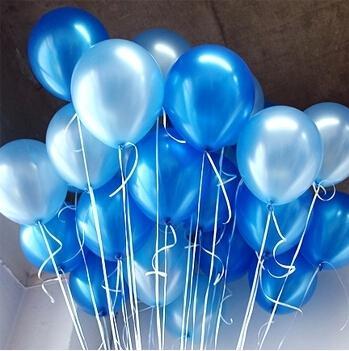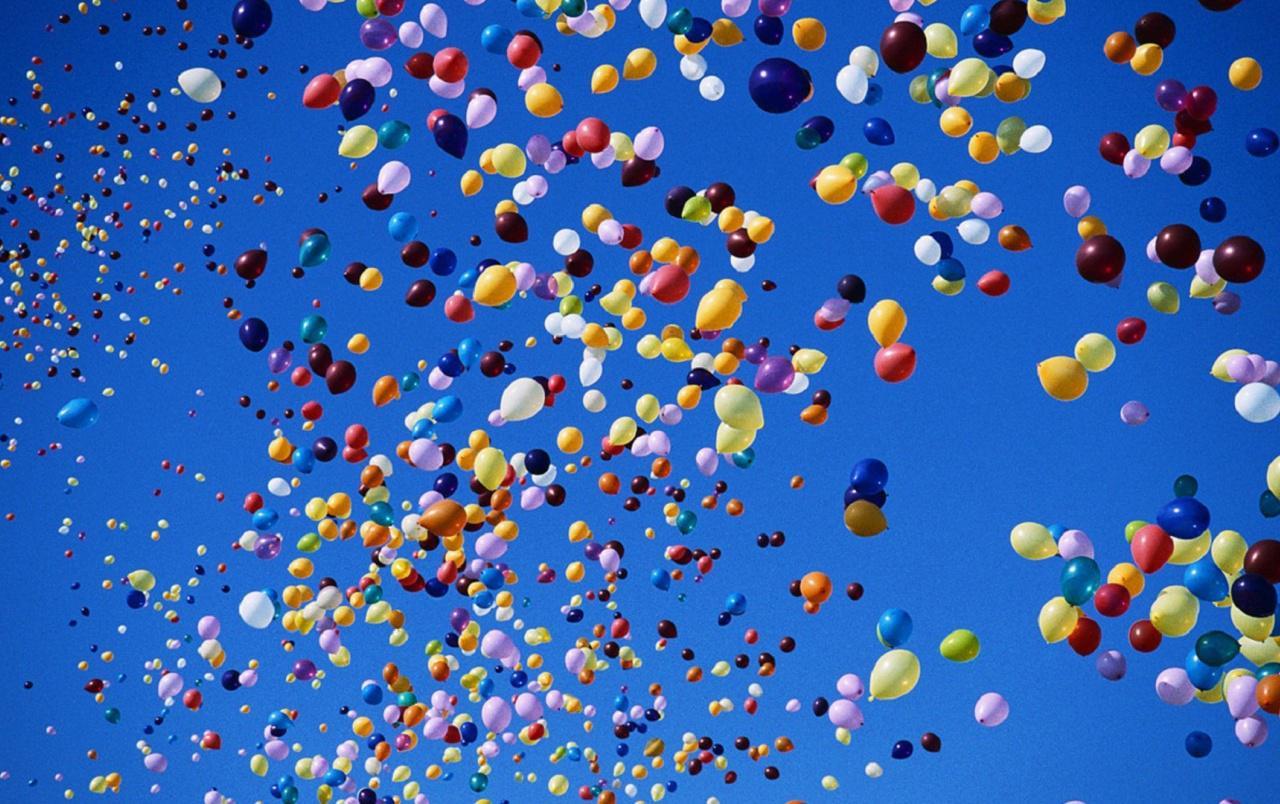The first image is the image on the left, the second image is the image on the right. Given the left and right images, does the statement "In at least one image there are hundreds of balloons being released into the sky." hold true? Answer yes or no. Yes. The first image is the image on the left, the second image is the image on the right. Examine the images to the left and right. Is the description "Balloons float in the air in one of the images." accurate? Answer yes or no. Yes. 